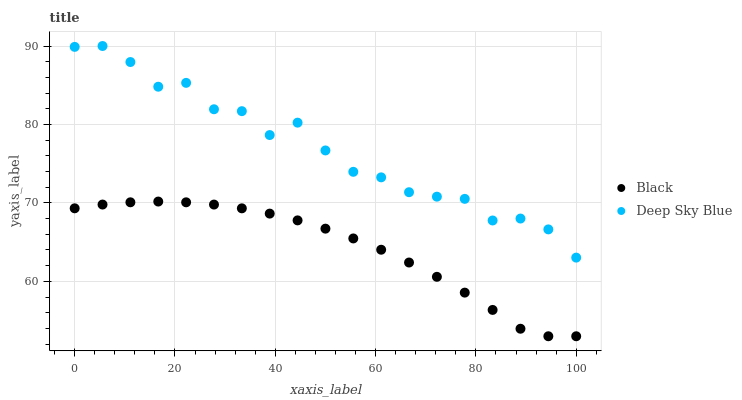Does Black have the minimum area under the curve?
Answer yes or no. Yes. Does Deep Sky Blue have the maximum area under the curve?
Answer yes or no. Yes. Does Deep Sky Blue have the minimum area under the curve?
Answer yes or no. No. Is Black the smoothest?
Answer yes or no. Yes. Is Deep Sky Blue the roughest?
Answer yes or no. Yes. Is Deep Sky Blue the smoothest?
Answer yes or no. No. Does Black have the lowest value?
Answer yes or no. Yes. Does Deep Sky Blue have the lowest value?
Answer yes or no. No. Does Deep Sky Blue have the highest value?
Answer yes or no. Yes. Is Black less than Deep Sky Blue?
Answer yes or no. Yes. Is Deep Sky Blue greater than Black?
Answer yes or no. Yes. Does Black intersect Deep Sky Blue?
Answer yes or no. No. 